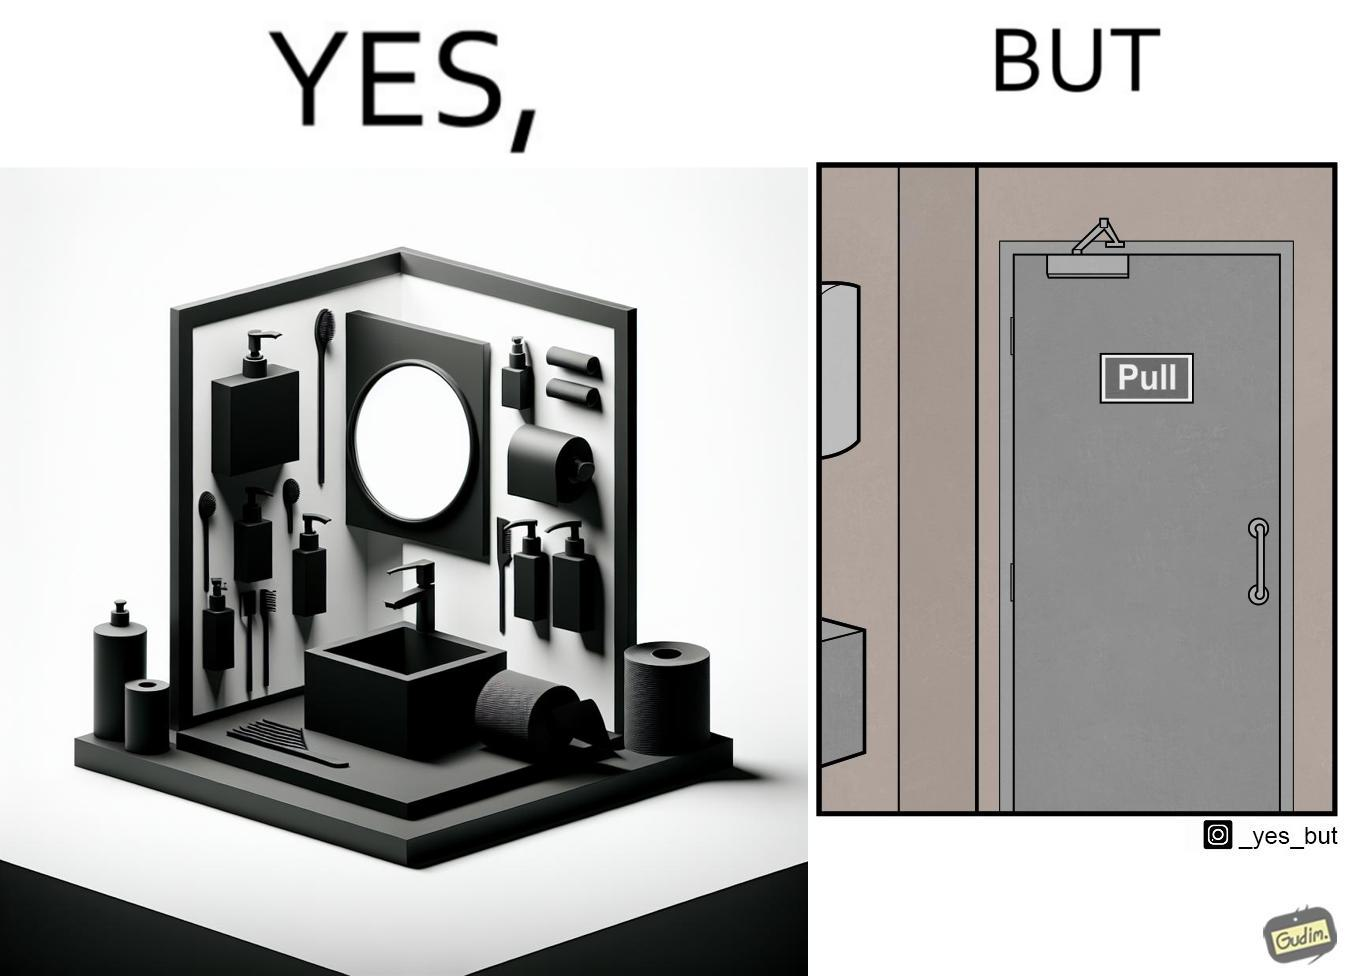Is this a satirical image? Yes, this image is satirical. 